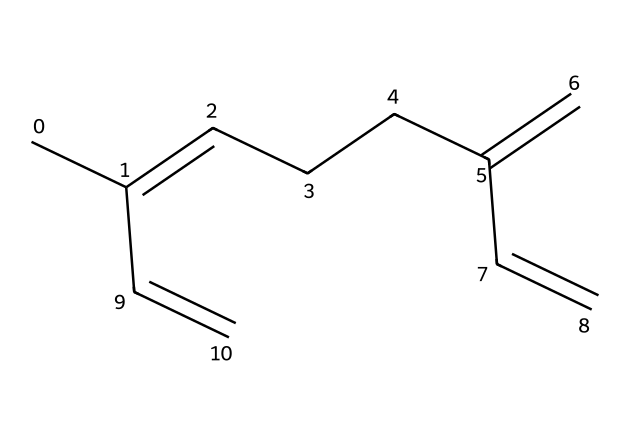What is the molecular formula of myrcene? To determine the molecular formula, count the number of carbon (C) and hydrogen (H) atoms in the SMILES representation. There are 10 carbon atoms and 16 hydrogen atoms. Therefore, the molecular formula is C10H16.
Answer: C10H16 How many double bonds are present in myrcene? In the SMILES structure, we count the '=' symbols that represent double bonds. There are three '=' in total, indicating that myrcene has three double bonds.
Answer: 3 What functional groups can be identified in myrcene? Myrcene contains only carbon-carbon double bonds, which characterize it as an alkene. There are no other functional groups present in the structure.
Answer: alkene What type of compound is myrcene classified as? Given its structure, which consists of hydrocarbons and its classification as a terpene, it is identified as a monoterpene because it contains 10 carbon atoms.
Answer: monoterpene Which part of the structure indicates that myrcene is unsaturated? The presence of multiple double bonds (depicted by the '=' in the structure) indicates unsaturation. This means that myrcene has fewer hydrogen atoms than a fully saturated alkane.
Answer: double bonds How does myrcene contribute to the aroma of hops? Myrcene’s unique structural features, including its unsaturated bonds, allow it to participate in distinct aromatic compounds, contributing to the characteristic smell of hops.
Answer: aroma-compound 